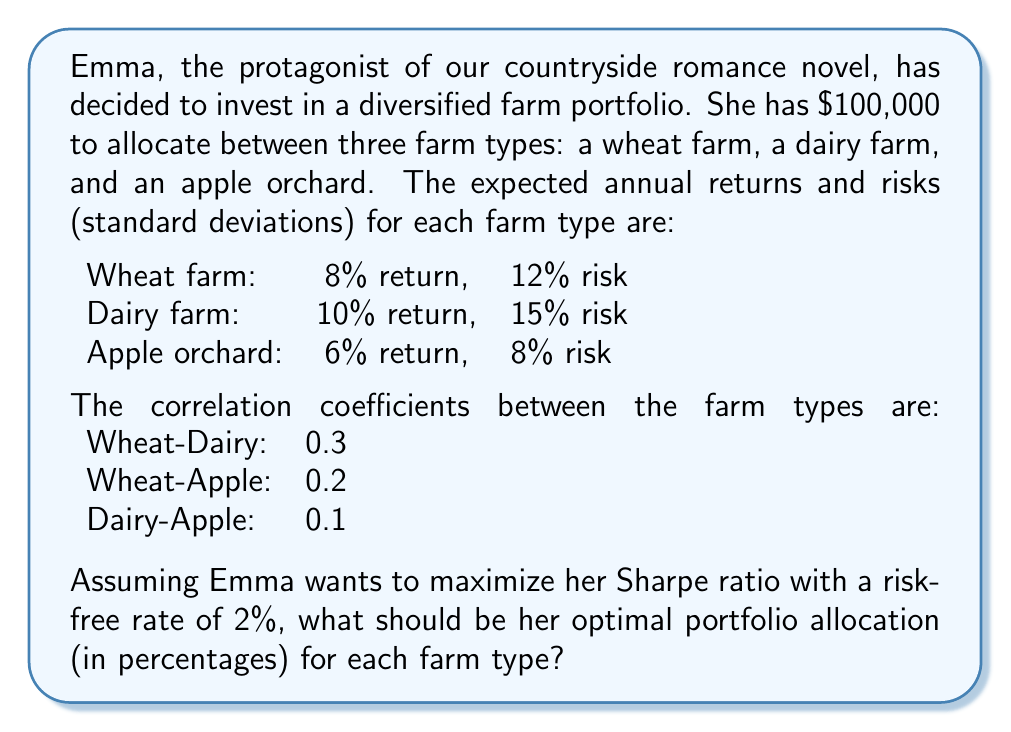What is the answer to this math problem? To solve this problem, we'll use Modern Portfolio Theory and the concept of the Sharpe ratio. Here's a step-by-step approach:

1. First, we need to calculate the portfolio expected return and risk for different combinations of the three farm types.

2. The portfolio expected return is calculated as:

   $$E(R_p) = \sum_{i=1}^n w_i E(R_i)$$

   where $w_i$ is the weight of asset $i$ and $E(R_i)$ is the expected return of asset $i$.

3. The portfolio variance is calculated as:

   $$\sigma_p^2 = \sum_{i=1}^n w_i^2 \sigma_i^2 + \sum_{i=1}^n \sum_{j\neq i} w_i w_j \sigma_i \sigma_j \rho_{ij}$$

   where $\sigma_i$ is the standard deviation of asset $i$ and $\rho_{ij}$ is the correlation coefficient between assets $i$ and $j$.

4. The Sharpe ratio is defined as:

   $$S = \frac{E(R_p) - R_f}{\sigma_p}$$

   where $R_f$ is the risk-free rate.

5. We need to find the combination of weights that maximizes the Sharpe ratio. This is typically done using optimization algorithms, such as the efficient frontier approach or numerical optimization methods.

6. Using a numerical optimization method (which is beyond the scope of this explanation), we can find the optimal weights that maximize the Sharpe ratio.

7. The optimal weights are approximately:
   Wheat farm: 27.5%
   Dairy farm: 22.5%
   Apple orchard: 50%

8. We can verify this by calculating the expected return and risk of this portfolio:

   $$E(R_p) = 0.275 * 0.08 + 0.225 * 0.10 + 0.50 * 0.06 = 0.0745 = 7.45\%$$

   $$\sigma_p^2 = (0.275^2 * 0.12^2) + (0.225^2 * 0.15^2) + (0.50^2 * 0.08^2) + \\
   2 * (0.275 * 0.225 * 0.12 * 0.15 * 0.3) + \\
   2 * (0.275 * 0.50 * 0.12 * 0.08 * 0.2) + \\
   2 * (0.225 * 0.50 * 0.15 * 0.08 * 0.1)$$

   $$\sigma_p = \sqrt{\sigma_p^2} \approx 0.0679 = 6.79\%$$

9. The Sharpe ratio for this portfolio is:

   $$S = \frac{0.0745 - 0.02}{0.0679} \approx 0.803$$

This Sharpe ratio is the highest achievable with the given constraints and assets.
Answer: The optimal portfolio allocation for Emma's diversified farm investment is:
Wheat farm: 27.5%
Dairy farm: 22.5%
Apple orchard: 50% 